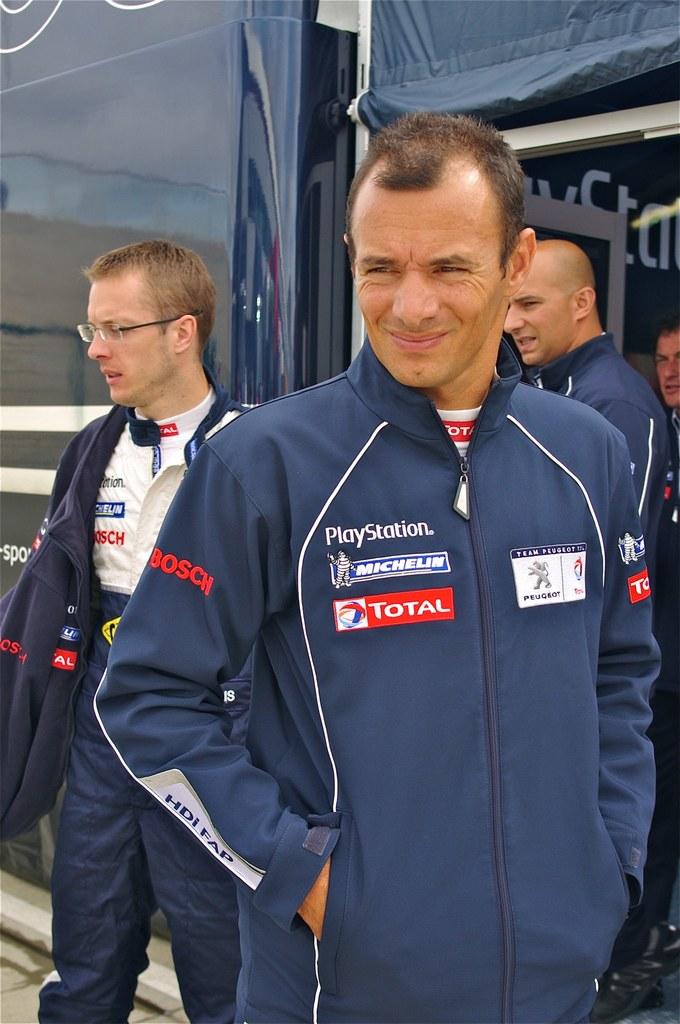What tire company sponsors this man?
Provide a succinct answer. Michelin. 